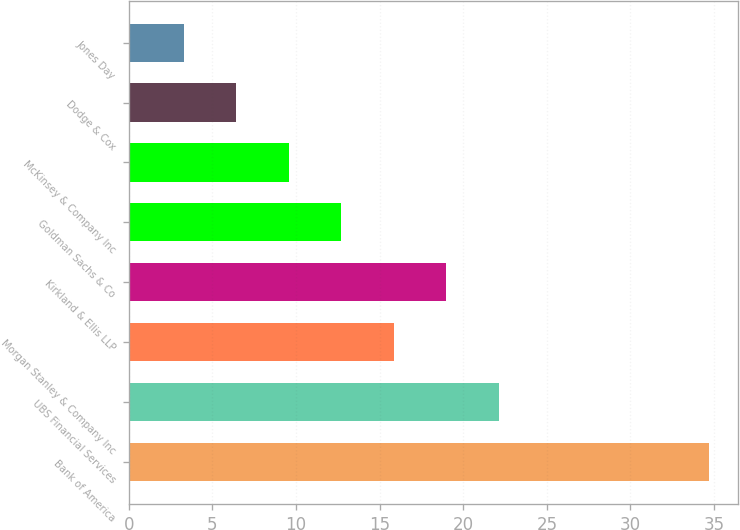<chart> <loc_0><loc_0><loc_500><loc_500><bar_chart><fcel>Bank of America<fcel>UBS Financial Services<fcel>Morgan Stanley & Company Inc<fcel>Kirkland & Ellis LLP<fcel>Goldman Sachs & Co<fcel>McKinsey & Company Inc<fcel>Dodge & Cox<fcel>Jones Day<nl><fcel>34.7<fcel>22.14<fcel>15.86<fcel>19<fcel>12.72<fcel>9.58<fcel>6.44<fcel>3.3<nl></chart> 